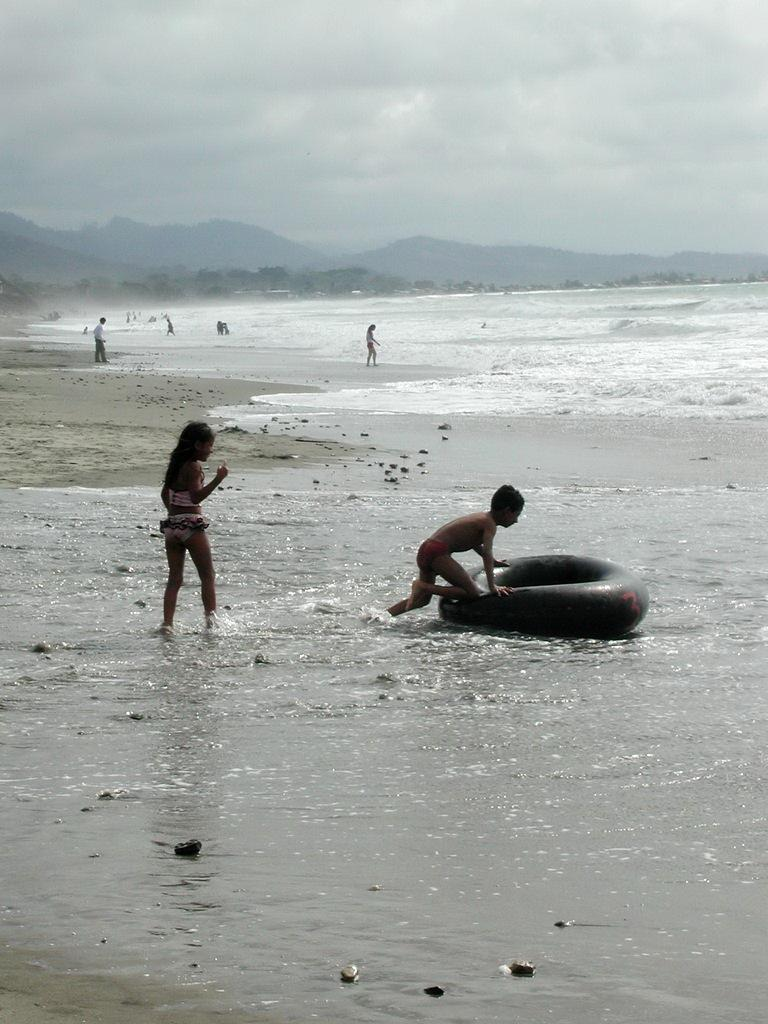Who is the main subject in the image? There is a boy in the image. What is the boy holding in the image? The boy is holding a swimming tube. Can you describe the people in the image? There are people in the image, but their specific actions or characteristics are not mentioned in the facts. What can be seen in the background of the image? There is a sea, hills, and the sky visible in the background of the image. What type of animals can be seen in the zoo in the image? There is no zoo present in the image; it features a boy holding a swimming tube and a background with a sea, hills, and the sky. What is the minister doing in the image? There is no minister present in the image. 